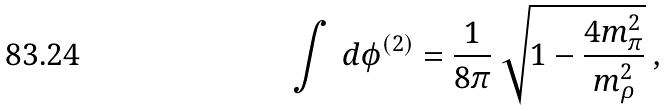Convert formula to latex. <formula><loc_0><loc_0><loc_500><loc_500>\int \, d \phi ^ { ( 2 ) } = \frac { 1 } { 8 \pi } \ \sqrt { 1 - \frac { 4 m _ { \pi } ^ { 2 } } { m _ { \rho } ^ { 2 } } } \ ,</formula> 